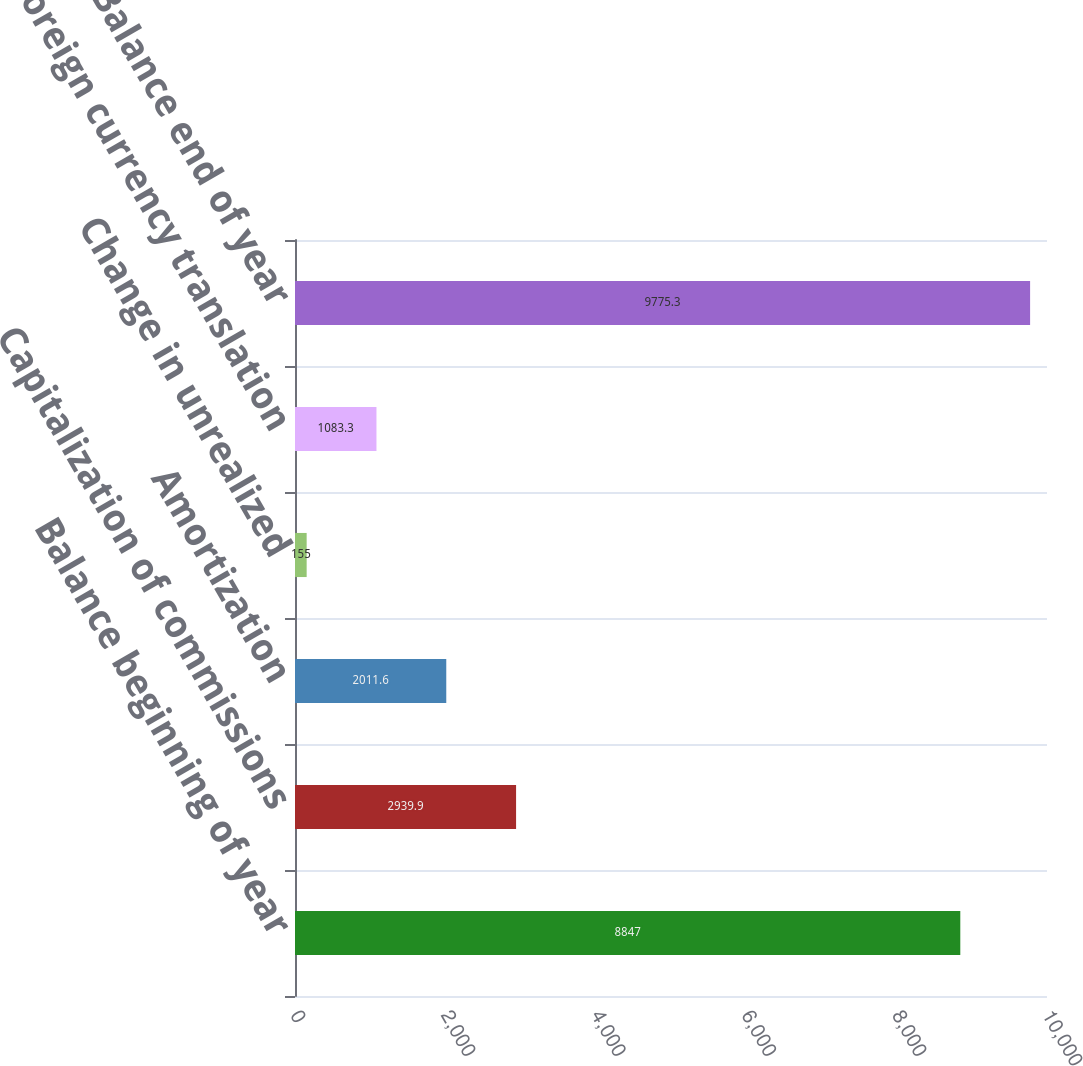<chart> <loc_0><loc_0><loc_500><loc_500><bar_chart><fcel>Balance beginning of year<fcel>Capitalization of commissions<fcel>Amortization<fcel>Change in unrealized<fcel>Foreign currency translation<fcel>Balance end of year<nl><fcel>8847<fcel>2939.9<fcel>2011.6<fcel>155<fcel>1083.3<fcel>9775.3<nl></chart> 